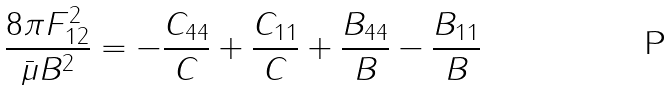<formula> <loc_0><loc_0><loc_500><loc_500>\frac { 8 \pi F ^ { 2 } _ { 1 2 } } { \bar { \mu } B ^ { 2 } } = - \frac { C _ { 4 4 } } { C } + \frac { C _ { 1 1 } } { C } + \frac { B _ { 4 4 } } { B } - \frac { B _ { 1 1 } } { B }</formula> 